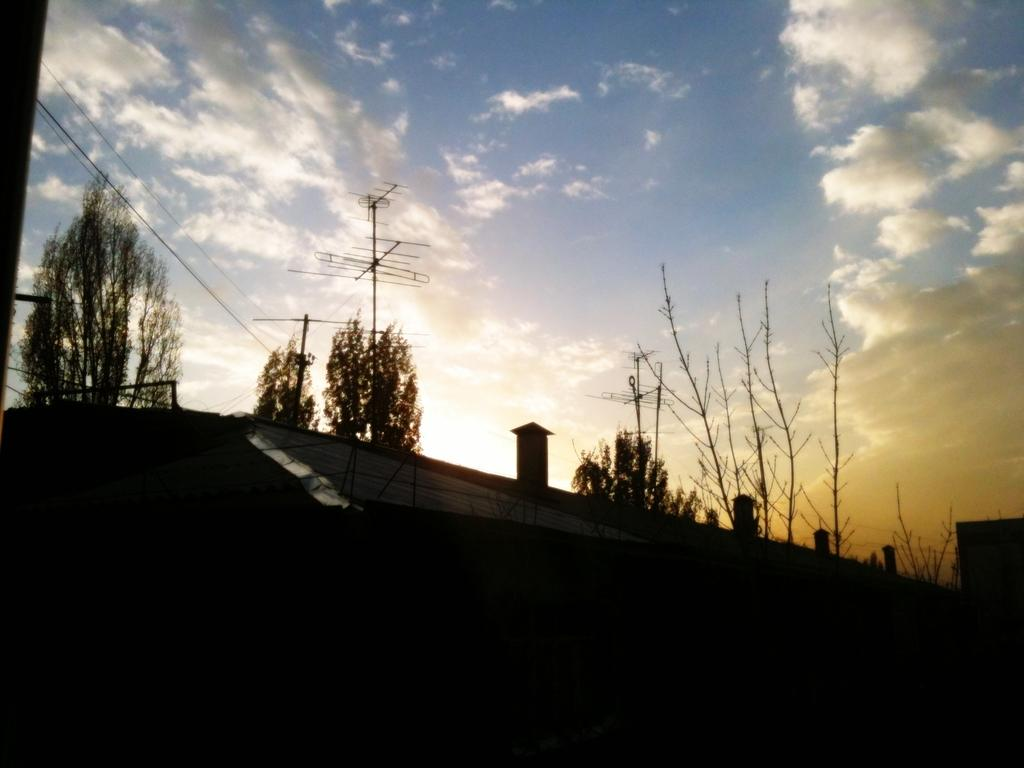What type of natural elements can be seen in the image? There are trees in the image. What man-made structures are visible in the image? There are antennas and wires in the image. How would you describe the sky in the image? The sky is blue and cloudy in the image. What is the lighting condition at the bottom of the image? There is a dark view at the bottom of the image. How does the temper of the trees change throughout the image? Trees do not have a temper; they are inanimate objects. The image only shows their presence and does not depict any changes in their condition. 